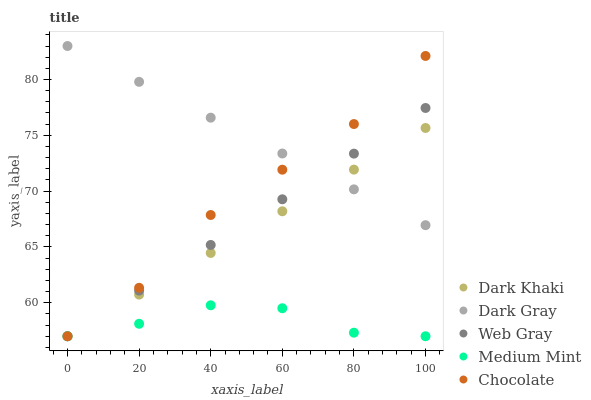Does Medium Mint have the minimum area under the curve?
Answer yes or no. Yes. Does Dark Gray have the maximum area under the curve?
Answer yes or no. Yes. Does Web Gray have the minimum area under the curve?
Answer yes or no. No. Does Web Gray have the maximum area under the curve?
Answer yes or no. No. Is Dark Gray the smoothest?
Answer yes or no. Yes. Is Chocolate the roughest?
Answer yes or no. Yes. Is Web Gray the smoothest?
Answer yes or no. No. Is Web Gray the roughest?
Answer yes or no. No. Does Dark Khaki have the lowest value?
Answer yes or no. Yes. Does Dark Gray have the lowest value?
Answer yes or no. No. Does Dark Gray have the highest value?
Answer yes or no. Yes. Does Web Gray have the highest value?
Answer yes or no. No. Is Medium Mint less than Dark Gray?
Answer yes or no. Yes. Is Dark Gray greater than Medium Mint?
Answer yes or no. Yes. Does Web Gray intersect Chocolate?
Answer yes or no. Yes. Is Web Gray less than Chocolate?
Answer yes or no. No. Is Web Gray greater than Chocolate?
Answer yes or no. No. Does Medium Mint intersect Dark Gray?
Answer yes or no. No. 